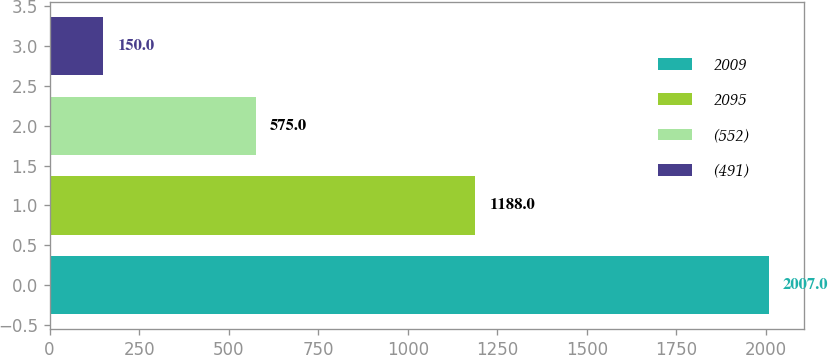<chart> <loc_0><loc_0><loc_500><loc_500><bar_chart><fcel>2009<fcel>2095<fcel>(552)<fcel>(491)<nl><fcel>2007<fcel>1188<fcel>575<fcel>150<nl></chart> 